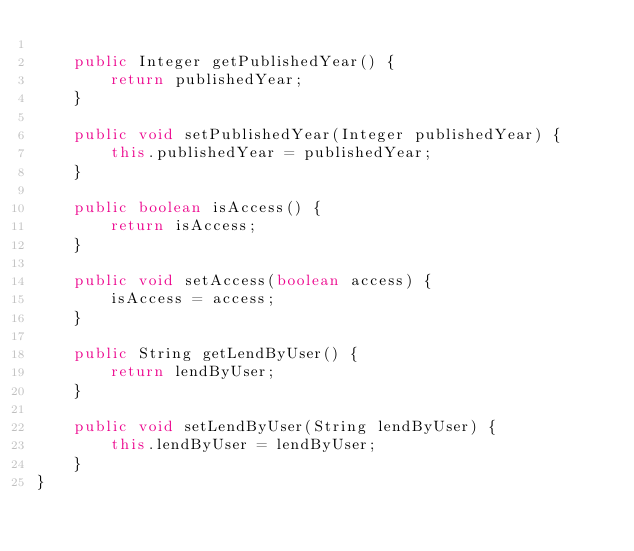<code> <loc_0><loc_0><loc_500><loc_500><_Java_>
    public Integer getPublishedYear() {
        return publishedYear;
    }

    public void setPublishedYear(Integer publishedYear) {
        this.publishedYear = publishedYear;
    }

    public boolean isAccess() {
        return isAccess;
    }

    public void setAccess(boolean access) {
        isAccess = access;
    }

    public String getLendByUser() {
        return lendByUser;
    }

    public void setLendByUser(String lendByUser) {
        this.lendByUser = lendByUser;
    }
}
</code> 